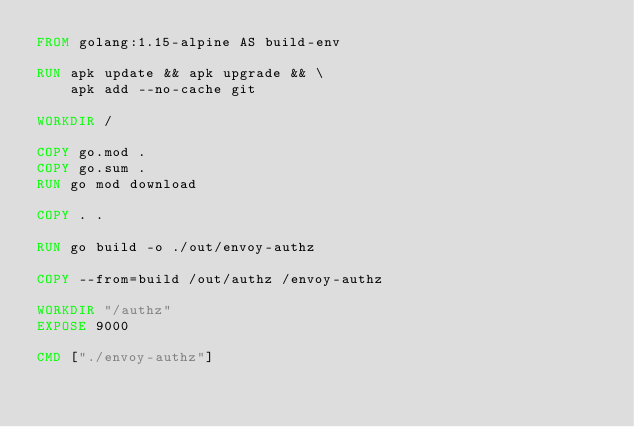<code> <loc_0><loc_0><loc_500><loc_500><_Dockerfile_>FROM golang:1.15-alpine AS build-env

RUN apk update && apk upgrade && \
    apk add --no-cache git

WORKDIR /  

COPY go.mod .
COPY go.sum .
RUN go mod download

COPY . .

RUN go build -o ./out/envoy-authz

COPY --from=build /out/authz /envoy-authz

WORKDIR "/authz"
EXPOSE 9000 

CMD ["./envoy-authz"]</code> 